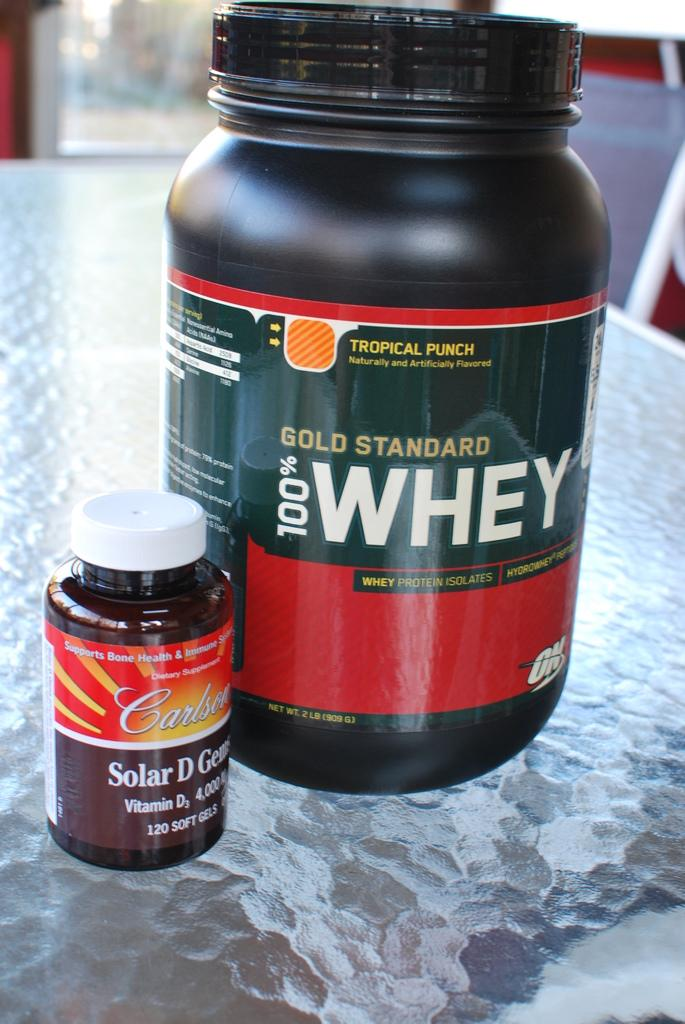<image>
Provide a brief description of the given image. A large bottle of Gold Standard 100% whey sits on a glass table. 